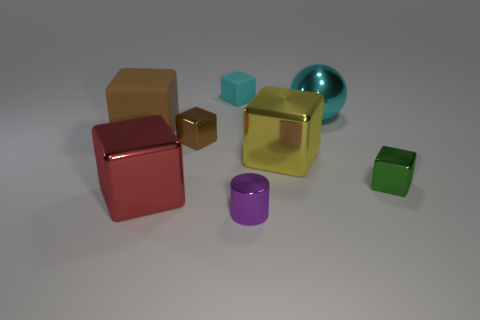How many things are red metal objects or large green rubber cubes?
Offer a terse response. 1. There is a metal object that is the same color as the big rubber thing; what is its size?
Make the answer very short. Small. There is a cyan metal sphere; are there any large red blocks behind it?
Offer a terse response. No. Is the number of big brown things in front of the small purple shiny cylinder greater than the number of large metal blocks that are left of the big red shiny cube?
Offer a terse response. No. What size is the yellow metal object that is the same shape as the red metal object?
Ensure brevity in your answer.  Large. How many spheres are either yellow things or large rubber objects?
Provide a succinct answer. 0. What material is the small cube that is the same color as the big matte object?
Your answer should be very brief. Metal. Is the number of purple cylinders to the left of the red block less than the number of yellow metal blocks in front of the small green thing?
Ensure brevity in your answer.  No. What number of objects are either metallic blocks that are to the left of the tiny green metallic thing or small blue rubber cylinders?
Give a very brief answer. 3. There is a small thing that is in front of the object on the right side of the big ball; what is its shape?
Your answer should be compact. Cylinder. 